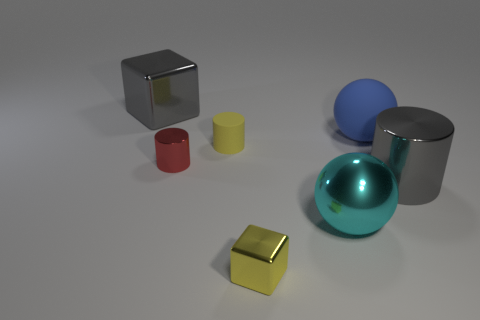Subtract all large gray cylinders. How many cylinders are left? 2 Subtract all cylinders. How many objects are left? 4 Subtract all gray cubes. How many cubes are left? 1 Subtract 1 cubes. How many cubes are left? 1 Subtract all red cylinders. How many gray spheres are left? 0 Subtract all large cyan metallic objects. Subtract all gray metal things. How many objects are left? 4 Add 2 big gray objects. How many big gray objects are left? 4 Add 2 tiny yellow blocks. How many tiny yellow blocks exist? 3 Add 2 tiny cylinders. How many objects exist? 9 Subtract 0 brown spheres. How many objects are left? 7 